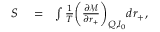<formula> <loc_0><loc_0><loc_500><loc_500>\begin{array} { r l r } { S } & = } & { \int \frac { 1 } { T } \left ( \frac { \partial \mathcal { M } } { \partial r _ { + } } \right ) _ { Q , l _ { 0 } } d r _ { + } , } \end{array}</formula> 